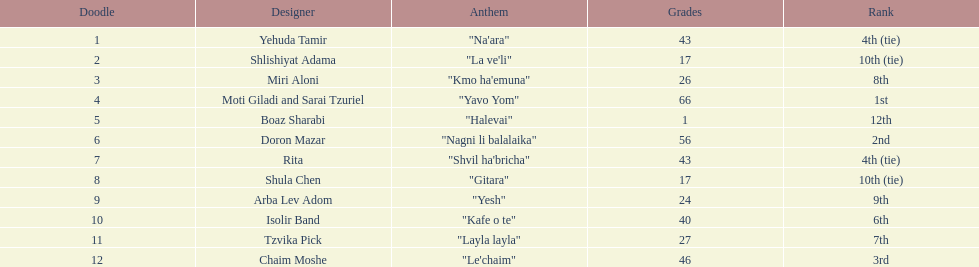How many points does the artist rita have? 43. 